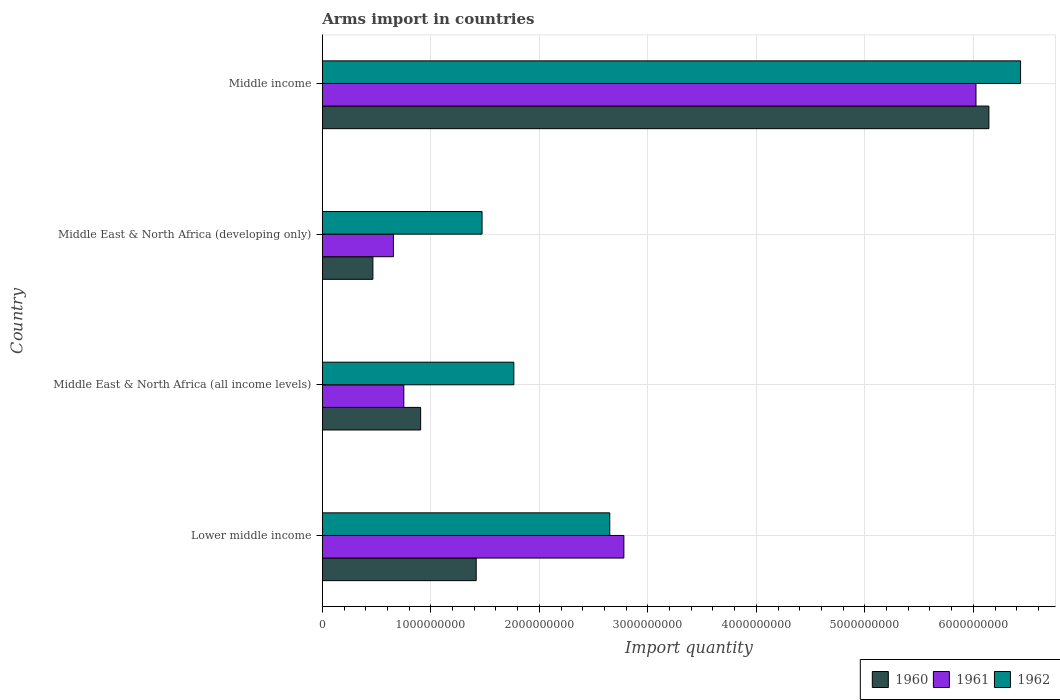Are the number of bars on each tick of the Y-axis equal?
Ensure brevity in your answer.  Yes. How many bars are there on the 1st tick from the bottom?
Provide a short and direct response. 3. In how many cases, is the number of bars for a given country not equal to the number of legend labels?
Provide a short and direct response. 0. What is the total arms import in 1962 in Lower middle income?
Provide a short and direct response. 2.65e+09. Across all countries, what is the maximum total arms import in 1962?
Give a very brief answer. 6.44e+09. Across all countries, what is the minimum total arms import in 1962?
Offer a terse response. 1.47e+09. In which country was the total arms import in 1960 maximum?
Provide a succinct answer. Middle income. In which country was the total arms import in 1961 minimum?
Your answer should be very brief. Middle East & North Africa (developing only). What is the total total arms import in 1961 in the graph?
Your answer should be compact. 1.02e+1. What is the difference between the total arms import in 1962 in Lower middle income and that in Middle income?
Provide a short and direct response. -3.79e+09. What is the difference between the total arms import in 1961 in Lower middle income and the total arms import in 1962 in Middle East & North Africa (developing only)?
Make the answer very short. 1.31e+09. What is the average total arms import in 1960 per country?
Provide a succinct answer. 2.23e+09. What is the difference between the total arms import in 1961 and total arms import in 1960 in Middle East & North Africa (all income levels)?
Offer a terse response. -1.55e+08. In how many countries, is the total arms import in 1961 greater than 1400000000 ?
Provide a succinct answer. 2. What is the ratio of the total arms import in 1961 in Middle East & North Africa (all income levels) to that in Middle income?
Offer a terse response. 0.12. Is the total arms import in 1961 in Middle East & North Africa (all income levels) less than that in Middle income?
Provide a short and direct response. Yes. Is the difference between the total arms import in 1961 in Lower middle income and Middle East & North Africa (developing only) greater than the difference between the total arms import in 1960 in Lower middle income and Middle East & North Africa (developing only)?
Give a very brief answer. Yes. What is the difference between the highest and the second highest total arms import in 1962?
Offer a very short reply. 3.79e+09. What is the difference between the highest and the lowest total arms import in 1960?
Give a very brief answer. 5.68e+09. Is the sum of the total arms import in 1960 in Lower middle income and Middle East & North Africa (all income levels) greater than the maximum total arms import in 1962 across all countries?
Your response must be concise. No. What does the 2nd bar from the top in Middle East & North Africa (developing only) represents?
Your answer should be very brief. 1961. Is it the case that in every country, the sum of the total arms import in 1960 and total arms import in 1962 is greater than the total arms import in 1961?
Make the answer very short. Yes. Are all the bars in the graph horizontal?
Offer a terse response. Yes. Does the graph contain grids?
Your answer should be compact. Yes. How are the legend labels stacked?
Give a very brief answer. Horizontal. What is the title of the graph?
Keep it short and to the point. Arms import in countries. What is the label or title of the X-axis?
Keep it short and to the point. Import quantity. What is the label or title of the Y-axis?
Offer a terse response. Country. What is the Import quantity in 1960 in Lower middle income?
Offer a very short reply. 1.42e+09. What is the Import quantity in 1961 in Lower middle income?
Make the answer very short. 2.78e+09. What is the Import quantity in 1962 in Lower middle income?
Ensure brevity in your answer.  2.65e+09. What is the Import quantity in 1960 in Middle East & North Africa (all income levels)?
Offer a very short reply. 9.06e+08. What is the Import quantity in 1961 in Middle East & North Africa (all income levels)?
Your answer should be compact. 7.51e+08. What is the Import quantity of 1962 in Middle East & North Africa (all income levels)?
Provide a succinct answer. 1.76e+09. What is the Import quantity in 1960 in Middle East & North Africa (developing only)?
Your answer should be compact. 4.66e+08. What is the Import quantity of 1961 in Middle East & North Africa (developing only)?
Give a very brief answer. 6.55e+08. What is the Import quantity in 1962 in Middle East & North Africa (developing only)?
Keep it short and to the point. 1.47e+09. What is the Import quantity in 1960 in Middle income?
Ensure brevity in your answer.  6.14e+09. What is the Import quantity in 1961 in Middle income?
Your answer should be compact. 6.02e+09. What is the Import quantity in 1962 in Middle income?
Offer a terse response. 6.44e+09. Across all countries, what is the maximum Import quantity in 1960?
Keep it short and to the point. 6.14e+09. Across all countries, what is the maximum Import quantity in 1961?
Offer a terse response. 6.02e+09. Across all countries, what is the maximum Import quantity in 1962?
Your answer should be compact. 6.44e+09. Across all countries, what is the minimum Import quantity of 1960?
Provide a succinct answer. 4.66e+08. Across all countries, what is the minimum Import quantity of 1961?
Give a very brief answer. 6.55e+08. Across all countries, what is the minimum Import quantity in 1962?
Your answer should be very brief. 1.47e+09. What is the total Import quantity of 1960 in the graph?
Keep it short and to the point. 8.93e+09. What is the total Import quantity of 1961 in the graph?
Make the answer very short. 1.02e+1. What is the total Import quantity in 1962 in the graph?
Offer a terse response. 1.23e+1. What is the difference between the Import quantity of 1960 in Lower middle income and that in Middle East & North Africa (all income levels)?
Your response must be concise. 5.12e+08. What is the difference between the Import quantity in 1961 in Lower middle income and that in Middle East & North Africa (all income levels)?
Make the answer very short. 2.03e+09. What is the difference between the Import quantity of 1962 in Lower middle income and that in Middle East & North Africa (all income levels)?
Make the answer very short. 8.84e+08. What is the difference between the Import quantity in 1960 in Lower middle income and that in Middle East & North Africa (developing only)?
Your answer should be compact. 9.52e+08. What is the difference between the Import quantity of 1961 in Lower middle income and that in Middle East & North Africa (developing only)?
Make the answer very short. 2.12e+09. What is the difference between the Import quantity of 1962 in Lower middle income and that in Middle East & North Africa (developing only)?
Your answer should be compact. 1.18e+09. What is the difference between the Import quantity of 1960 in Lower middle income and that in Middle income?
Your response must be concise. -4.72e+09. What is the difference between the Import quantity of 1961 in Lower middle income and that in Middle income?
Your answer should be compact. -3.24e+09. What is the difference between the Import quantity in 1962 in Lower middle income and that in Middle income?
Make the answer very short. -3.79e+09. What is the difference between the Import quantity in 1960 in Middle East & North Africa (all income levels) and that in Middle East & North Africa (developing only)?
Your answer should be compact. 4.40e+08. What is the difference between the Import quantity of 1961 in Middle East & North Africa (all income levels) and that in Middle East & North Africa (developing only)?
Your response must be concise. 9.60e+07. What is the difference between the Import quantity in 1962 in Middle East & North Africa (all income levels) and that in Middle East & North Africa (developing only)?
Your answer should be very brief. 2.93e+08. What is the difference between the Import quantity in 1960 in Middle East & North Africa (all income levels) and that in Middle income?
Make the answer very short. -5.24e+09. What is the difference between the Import quantity in 1961 in Middle East & North Africa (all income levels) and that in Middle income?
Your answer should be very brief. -5.27e+09. What is the difference between the Import quantity of 1962 in Middle East & North Africa (all income levels) and that in Middle income?
Offer a terse response. -4.67e+09. What is the difference between the Import quantity of 1960 in Middle East & North Africa (developing only) and that in Middle income?
Offer a terse response. -5.68e+09. What is the difference between the Import quantity of 1961 in Middle East & North Africa (developing only) and that in Middle income?
Give a very brief answer. -5.37e+09. What is the difference between the Import quantity of 1962 in Middle East & North Africa (developing only) and that in Middle income?
Your answer should be very brief. -4.96e+09. What is the difference between the Import quantity in 1960 in Lower middle income and the Import quantity in 1961 in Middle East & North Africa (all income levels)?
Provide a short and direct response. 6.67e+08. What is the difference between the Import quantity in 1960 in Lower middle income and the Import quantity in 1962 in Middle East & North Africa (all income levels)?
Offer a terse response. -3.47e+08. What is the difference between the Import quantity of 1961 in Lower middle income and the Import quantity of 1962 in Middle East & North Africa (all income levels)?
Make the answer very short. 1.01e+09. What is the difference between the Import quantity in 1960 in Lower middle income and the Import quantity in 1961 in Middle East & North Africa (developing only)?
Offer a terse response. 7.63e+08. What is the difference between the Import quantity of 1960 in Lower middle income and the Import quantity of 1962 in Middle East & North Africa (developing only)?
Provide a succinct answer. -5.40e+07. What is the difference between the Import quantity of 1961 in Lower middle income and the Import quantity of 1962 in Middle East & North Africa (developing only)?
Offer a terse response. 1.31e+09. What is the difference between the Import quantity of 1960 in Lower middle income and the Import quantity of 1961 in Middle income?
Your answer should be very brief. -4.61e+09. What is the difference between the Import quantity of 1960 in Lower middle income and the Import quantity of 1962 in Middle income?
Your answer should be very brief. -5.02e+09. What is the difference between the Import quantity in 1961 in Lower middle income and the Import quantity in 1962 in Middle income?
Your answer should be compact. -3.66e+09. What is the difference between the Import quantity of 1960 in Middle East & North Africa (all income levels) and the Import quantity of 1961 in Middle East & North Africa (developing only)?
Your answer should be compact. 2.51e+08. What is the difference between the Import quantity in 1960 in Middle East & North Africa (all income levels) and the Import quantity in 1962 in Middle East & North Africa (developing only)?
Ensure brevity in your answer.  -5.66e+08. What is the difference between the Import quantity in 1961 in Middle East & North Africa (all income levels) and the Import quantity in 1962 in Middle East & North Africa (developing only)?
Offer a terse response. -7.21e+08. What is the difference between the Import quantity of 1960 in Middle East & North Africa (all income levels) and the Import quantity of 1961 in Middle income?
Ensure brevity in your answer.  -5.12e+09. What is the difference between the Import quantity of 1960 in Middle East & North Africa (all income levels) and the Import quantity of 1962 in Middle income?
Offer a very short reply. -5.53e+09. What is the difference between the Import quantity in 1961 in Middle East & North Africa (all income levels) and the Import quantity in 1962 in Middle income?
Offer a terse response. -5.68e+09. What is the difference between the Import quantity of 1960 in Middle East & North Africa (developing only) and the Import quantity of 1961 in Middle income?
Give a very brief answer. -5.56e+09. What is the difference between the Import quantity in 1960 in Middle East & North Africa (developing only) and the Import quantity in 1962 in Middle income?
Offer a terse response. -5.97e+09. What is the difference between the Import quantity of 1961 in Middle East & North Africa (developing only) and the Import quantity of 1962 in Middle income?
Keep it short and to the point. -5.78e+09. What is the average Import quantity in 1960 per country?
Keep it short and to the point. 2.23e+09. What is the average Import quantity of 1961 per country?
Make the answer very short. 2.55e+09. What is the average Import quantity in 1962 per country?
Give a very brief answer. 3.08e+09. What is the difference between the Import quantity of 1960 and Import quantity of 1961 in Lower middle income?
Ensure brevity in your answer.  -1.36e+09. What is the difference between the Import quantity in 1960 and Import quantity in 1962 in Lower middle income?
Keep it short and to the point. -1.23e+09. What is the difference between the Import quantity in 1961 and Import quantity in 1962 in Lower middle income?
Ensure brevity in your answer.  1.30e+08. What is the difference between the Import quantity in 1960 and Import quantity in 1961 in Middle East & North Africa (all income levels)?
Make the answer very short. 1.55e+08. What is the difference between the Import quantity of 1960 and Import quantity of 1962 in Middle East & North Africa (all income levels)?
Offer a very short reply. -8.59e+08. What is the difference between the Import quantity in 1961 and Import quantity in 1962 in Middle East & North Africa (all income levels)?
Offer a very short reply. -1.01e+09. What is the difference between the Import quantity of 1960 and Import quantity of 1961 in Middle East & North Africa (developing only)?
Make the answer very short. -1.89e+08. What is the difference between the Import quantity in 1960 and Import quantity in 1962 in Middle East & North Africa (developing only)?
Make the answer very short. -1.01e+09. What is the difference between the Import quantity of 1961 and Import quantity of 1962 in Middle East & North Africa (developing only)?
Provide a short and direct response. -8.17e+08. What is the difference between the Import quantity of 1960 and Import quantity of 1961 in Middle income?
Provide a succinct answer. 1.19e+08. What is the difference between the Import quantity in 1960 and Import quantity in 1962 in Middle income?
Give a very brief answer. -2.92e+08. What is the difference between the Import quantity in 1961 and Import quantity in 1962 in Middle income?
Give a very brief answer. -4.11e+08. What is the ratio of the Import quantity of 1960 in Lower middle income to that in Middle East & North Africa (all income levels)?
Ensure brevity in your answer.  1.57. What is the ratio of the Import quantity in 1961 in Lower middle income to that in Middle East & North Africa (all income levels)?
Keep it short and to the point. 3.7. What is the ratio of the Import quantity in 1962 in Lower middle income to that in Middle East & North Africa (all income levels)?
Provide a short and direct response. 1.5. What is the ratio of the Import quantity of 1960 in Lower middle income to that in Middle East & North Africa (developing only)?
Your response must be concise. 3.04. What is the ratio of the Import quantity of 1961 in Lower middle income to that in Middle East & North Africa (developing only)?
Offer a very short reply. 4.24. What is the ratio of the Import quantity of 1962 in Lower middle income to that in Middle East & North Africa (developing only)?
Your answer should be compact. 1.8. What is the ratio of the Import quantity in 1960 in Lower middle income to that in Middle income?
Offer a very short reply. 0.23. What is the ratio of the Import quantity of 1961 in Lower middle income to that in Middle income?
Your response must be concise. 0.46. What is the ratio of the Import quantity of 1962 in Lower middle income to that in Middle income?
Offer a terse response. 0.41. What is the ratio of the Import quantity of 1960 in Middle East & North Africa (all income levels) to that in Middle East & North Africa (developing only)?
Provide a succinct answer. 1.94. What is the ratio of the Import quantity in 1961 in Middle East & North Africa (all income levels) to that in Middle East & North Africa (developing only)?
Provide a succinct answer. 1.15. What is the ratio of the Import quantity in 1962 in Middle East & North Africa (all income levels) to that in Middle East & North Africa (developing only)?
Your response must be concise. 1.2. What is the ratio of the Import quantity in 1960 in Middle East & North Africa (all income levels) to that in Middle income?
Your answer should be very brief. 0.15. What is the ratio of the Import quantity of 1961 in Middle East & North Africa (all income levels) to that in Middle income?
Offer a very short reply. 0.12. What is the ratio of the Import quantity of 1962 in Middle East & North Africa (all income levels) to that in Middle income?
Ensure brevity in your answer.  0.27. What is the ratio of the Import quantity of 1960 in Middle East & North Africa (developing only) to that in Middle income?
Your answer should be compact. 0.08. What is the ratio of the Import quantity of 1961 in Middle East & North Africa (developing only) to that in Middle income?
Offer a very short reply. 0.11. What is the ratio of the Import quantity in 1962 in Middle East & North Africa (developing only) to that in Middle income?
Provide a succinct answer. 0.23. What is the difference between the highest and the second highest Import quantity of 1960?
Provide a short and direct response. 4.72e+09. What is the difference between the highest and the second highest Import quantity of 1961?
Ensure brevity in your answer.  3.24e+09. What is the difference between the highest and the second highest Import quantity in 1962?
Provide a succinct answer. 3.79e+09. What is the difference between the highest and the lowest Import quantity in 1960?
Give a very brief answer. 5.68e+09. What is the difference between the highest and the lowest Import quantity of 1961?
Your response must be concise. 5.37e+09. What is the difference between the highest and the lowest Import quantity of 1962?
Your response must be concise. 4.96e+09. 